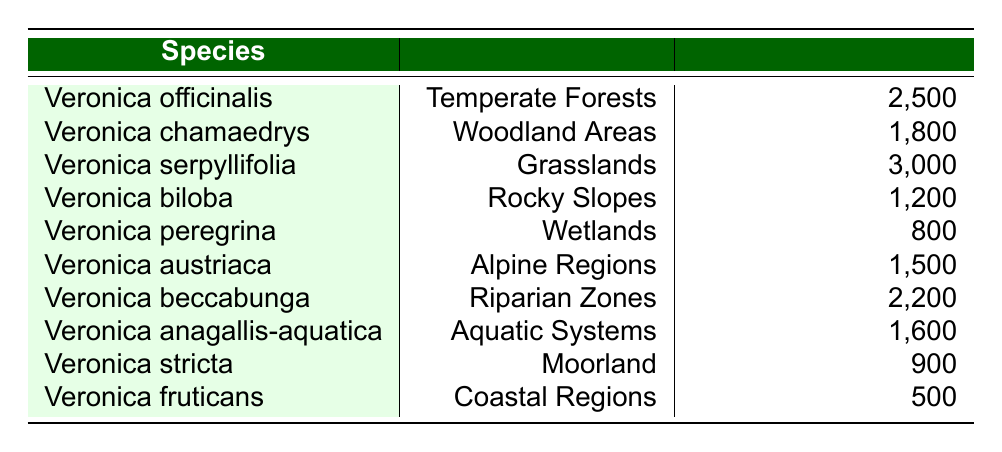What is the population estimate for Veronica serpyllifolia? The table directly lists the population estimate for Veronica serpyllifolia, which is found in the "Grasslands" ecological region. The corresponding population estimate is noted as 3000.
Answer: 3000 Which species are found in Coastal Regions and what is their population estimate? The table indicates that there is one species found in Coastal Regions, which is Veronica fruticans, with a population estimate of 500.
Answer: Veronica fruticans, 500 How many species have a population estimate greater than 2000? To find this, we need to review the population estimates: Veronica serpyllifolia (3000), Veronica beccabunga (2200), and Veronica officinalis (2500). Counting these, three species have a population above 2000.
Answer: 3 Is the population estimate for Veronica austriaca greater than that of Veronica biloba? The population estimate for Veronica austriaca is 1500, while for Veronica biloba it is 1200. Since 1500 is greater than 1200, the answer is yes.
Answer: Yes What is the total population estimate for species in Wetlands and Riparian Zones? Veronica peregrina in Wetlands has a population estimate of 800, and Veronica beccabunga in Riparian Zones has a population estimate of 2200. Summing these gives us 800 + 2200 = 3000.
Answer: 3000 Which ecological region has the lowest population estimate and what is that estimate? By checking the population estimates, we see that Coastal Regions have the lowest estimate, with Veronica fruticans at 500. Thus, the lowest population estimate is 500.
Answer: 500 What is the average population estimate of species found in Alpine Regions and Moorland? There is one species in Alpine Regions (Veronica austriaca, 1500) and one in Moorland (Veronica stricta, 900). The average is calculated as (1500 + 900) / 2 = 1200.
Answer: 1200 Does Veronica chamaedrys have a higher population estimate than Veronica anagallis-aquatica? Veronica chamaedrys has a population estimate of 1800 while Veronica anagallis-aquatica has an estimate of 1600. Since 1800 is greater than 1600, the answer is yes.
Answer: Yes What is the difference between the population estimates of the species in Grasslands and Wetlands? Veronica serpyllifolia in Grasslands has a population of 3000 and Veronica peregrina in Wetlands has 800. The difference is calculated as 3000 - 800 = 2200.
Answer: 2200 